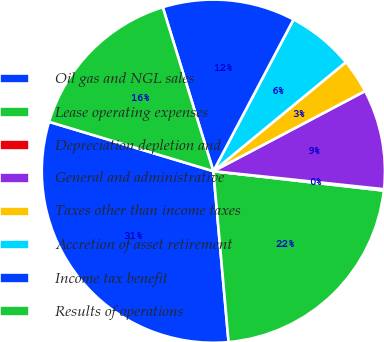Convert chart to OTSL. <chart><loc_0><loc_0><loc_500><loc_500><pie_chart><fcel>Oil gas and NGL sales<fcel>Lease operating expenses<fcel>Depreciation depletion and<fcel>General and administrative<fcel>Taxes other than income taxes<fcel>Accretion of asset retirement<fcel>Income tax benefit<fcel>Results of operations<nl><fcel>31.06%<fcel>21.78%<fcel>0.13%<fcel>9.41%<fcel>3.22%<fcel>6.31%<fcel>12.5%<fcel>15.59%<nl></chart> 